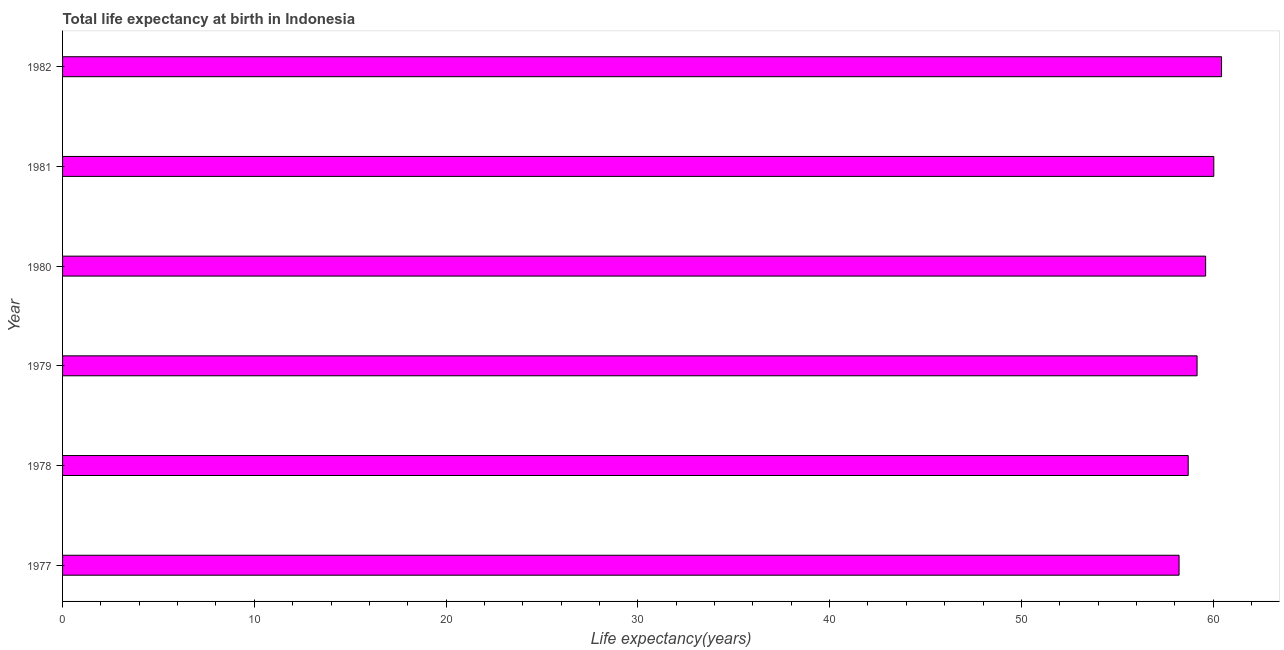What is the title of the graph?
Offer a very short reply. Total life expectancy at birth in Indonesia. What is the label or title of the X-axis?
Give a very brief answer. Life expectancy(years). What is the life expectancy at birth in 1981?
Provide a short and direct response. 60.04. Across all years, what is the maximum life expectancy at birth?
Offer a terse response. 60.44. Across all years, what is the minimum life expectancy at birth?
Your answer should be very brief. 58.23. What is the sum of the life expectancy at birth?
Offer a terse response. 356.17. What is the difference between the life expectancy at birth in 1980 and 1982?
Offer a very short reply. -0.83. What is the average life expectancy at birth per year?
Provide a short and direct response. 59.36. What is the median life expectancy at birth?
Provide a short and direct response. 59.39. Do a majority of the years between 1982 and 1978 (inclusive) have life expectancy at birth greater than 30 years?
Give a very brief answer. Yes. What is the ratio of the life expectancy at birth in 1978 to that in 1982?
Your response must be concise. 0.97. Is the difference between the life expectancy at birth in 1977 and 1980 greater than the difference between any two years?
Provide a succinct answer. No. What is the difference between the highest and the second highest life expectancy at birth?
Provide a short and direct response. 0.4. Is the sum of the life expectancy at birth in 1977 and 1979 greater than the maximum life expectancy at birth across all years?
Provide a succinct answer. Yes. What is the difference between the highest and the lowest life expectancy at birth?
Make the answer very short. 2.21. Are all the bars in the graph horizontal?
Offer a terse response. Yes. How many years are there in the graph?
Keep it short and to the point. 6. What is the Life expectancy(years) in 1977?
Provide a succinct answer. 58.23. What is the Life expectancy(years) of 1978?
Ensure brevity in your answer.  58.7. What is the Life expectancy(years) of 1979?
Offer a terse response. 59.16. What is the Life expectancy(years) in 1980?
Your response must be concise. 59.61. What is the Life expectancy(years) in 1981?
Keep it short and to the point. 60.04. What is the Life expectancy(years) of 1982?
Keep it short and to the point. 60.44. What is the difference between the Life expectancy(years) in 1977 and 1978?
Your response must be concise. -0.48. What is the difference between the Life expectancy(years) in 1977 and 1979?
Ensure brevity in your answer.  -0.94. What is the difference between the Life expectancy(years) in 1977 and 1980?
Keep it short and to the point. -1.38. What is the difference between the Life expectancy(years) in 1977 and 1981?
Keep it short and to the point. -1.81. What is the difference between the Life expectancy(years) in 1977 and 1982?
Offer a terse response. -2.21. What is the difference between the Life expectancy(years) in 1978 and 1979?
Keep it short and to the point. -0.46. What is the difference between the Life expectancy(years) in 1978 and 1980?
Offer a very short reply. -0.91. What is the difference between the Life expectancy(years) in 1978 and 1981?
Ensure brevity in your answer.  -1.33. What is the difference between the Life expectancy(years) in 1978 and 1982?
Provide a succinct answer. -1.74. What is the difference between the Life expectancy(years) in 1979 and 1980?
Make the answer very short. -0.45. What is the difference between the Life expectancy(years) in 1979 and 1981?
Keep it short and to the point. -0.87. What is the difference between the Life expectancy(years) in 1979 and 1982?
Your answer should be compact. -1.28. What is the difference between the Life expectancy(years) in 1980 and 1981?
Make the answer very short. -0.43. What is the difference between the Life expectancy(years) in 1980 and 1982?
Offer a terse response. -0.83. What is the difference between the Life expectancy(years) in 1981 and 1982?
Give a very brief answer. -0.4. What is the ratio of the Life expectancy(years) in 1977 to that in 1979?
Provide a succinct answer. 0.98. What is the ratio of the Life expectancy(years) in 1977 to that in 1981?
Provide a short and direct response. 0.97. What is the ratio of the Life expectancy(years) in 1979 to that in 1980?
Offer a very short reply. 0.99. What is the ratio of the Life expectancy(years) in 1979 to that in 1981?
Your answer should be very brief. 0.98. What is the ratio of the Life expectancy(years) in 1980 to that in 1982?
Offer a terse response. 0.99. What is the ratio of the Life expectancy(years) in 1981 to that in 1982?
Ensure brevity in your answer.  0.99. 